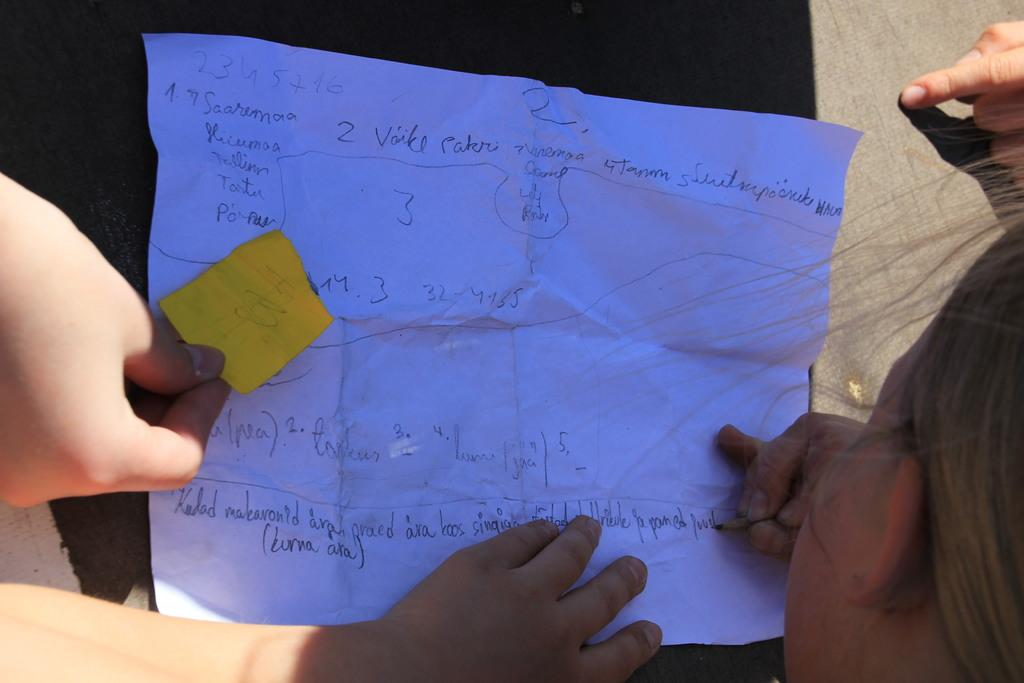What is the main subject of the image? The main subject of the image is a group of people. What are the people in the image interacting with? The people in the image are interacting with papers that are in front of them. Can you describe the content of the papers? The papers have text visible on them. What type of stone can be seen in the image? There is no stone present in the image; it features a group of people interacting with papers. What route are the people taking in the image? The image does not depict a route or any movement; it shows a stationary group of people with papers in front of them. 